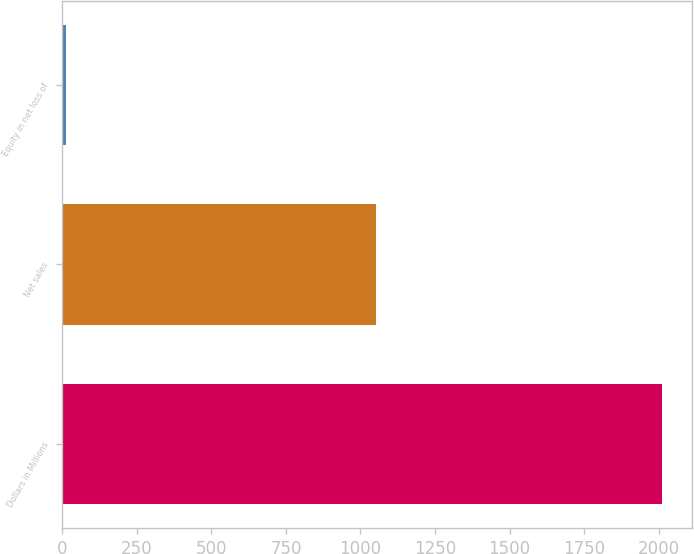Convert chart. <chart><loc_0><loc_0><loc_500><loc_500><bar_chart><fcel>Dollars in Millions<fcel>Net sales<fcel>Equity in net loss of<nl><fcel>2010<fcel>1053<fcel>12<nl></chart> 